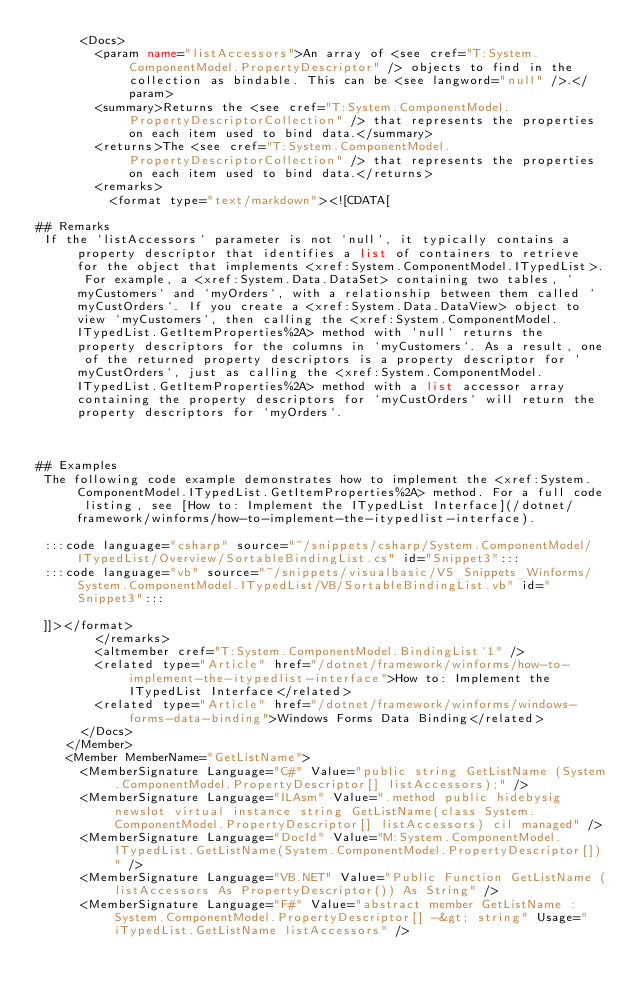<code> <loc_0><loc_0><loc_500><loc_500><_XML_>      <Docs>
        <param name="listAccessors">An array of <see cref="T:System.ComponentModel.PropertyDescriptor" /> objects to find in the collection as bindable. This can be <see langword="null" />.</param>
        <summary>Returns the <see cref="T:System.ComponentModel.PropertyDescriptorCollection" /> that represents the properties on each item used to bind data.</summary>
        <returns>The <see cref="T:System.ComponentModel.PropertyDescriptorCollection" /> that represents the properties on each item used to bind data.</returns>
        <remarks>
          <format type="text/markdown"><![CDATA[  
  
## Remarks  
 If the `listAccessors` parameter is not `null`, it typically contains a property descriptor that identifies a list of containers to retrieve for the object that implements <xref:System.ComponentModel.ITypedList>. For example, a <xref:System.Data.DataSet> containing two tables, `myCustomers` and `myOrders`, with a relationship between them called `myCustOrders`. If you create a <xref:System.Data.DataView> object to view `myCustomers`, then calling the <xref:System.ComponentModel.ITypedList.GetItemProperties%2A> method with `null` returns the property descriptors for the columns in `myCustomers`. As a result, one of the returned property descriptors is a property descriptor for `myCustOrders`, just as calling the <xref:System.ComponentModel.ITypedList.GetItemProperties%2A> method with a list accessor array containing the property descriptors for `myCustOrders` will return the property descriptors for `myOrders`.  
  
   
  
## Examples  
 The following code example demonstrates how to implement the <xref:System.ComponentModel.ITypedList.GetItemProperties%2A> method. For a full code listing, see [How to: Implement the ITypedList Interface](/dotnet/framework/winforms/how-to-implement-the-itypedlist-interface).  
  
 :::code language="csharp" source="~/snippets/csharp/System.ComponentModel/ITypedList/Overview/SortableBindingList.cs" id="Snippet3":::
 :::code language="vb" source="~/snippets/visualbasic/VS_Snippets_Winforms/System.ComponentModel.ITypedList/VB/SortableBindingList.vb" id="Snippet3":::  
  
 ]]></format>
        </remarks>
        <altmember cref="T:System.ComponentModel.BindingList`1" />
        <related type="Article" href="/dotnet/framework/winforms/how-to-implement-the-itypedlist-interface">How to: Implement the ITypedList Interface</related>
        <related type="Article" href="/dotnet/framework/winforms/windows-forms-data-binding">Windows Forms Data Binding</related>
      </Docs>
    </Member>
    <Member MemberName="GetListName">
      <MemberSignature Language="C#" Value="public string GetListName (System.ComponentModel.PropertyDescriptor[] listAccessors);" />
      <MemberSignature Language="ILAsm" Value=".method public hidebysig newslot virtual instance string GetListName(class System.ComponentModel.PropertyDescriptor[] listAccessors) cil managed" />
      <MemberSignature Language="DocId" Value="M:System.ComponentModel.ITypedList.GetListName(System.ComponentModel.PropertyDescriptor[])" />
      <MemberSignature Language="VB.NET" Value="Public Function GetListName (listAccessors As PropertyDescriptor()) As String" />
      <MemberSignature Language="F#" Value="abstract member GetListName : System.ComponentModel.PropertyDescriptor[] -&gt; string" Usage="iTypedList.GetListName listAccessors" /></code> 